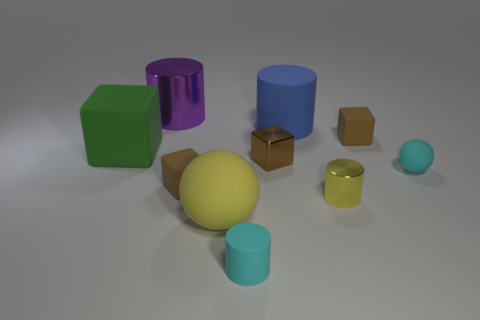How many cyan things are either big metal cylinders or balls?
Give a very brief answer. 1. Is there any other thing that has the same color as the large shiny cylinder?
Offer a terse response. No. What color is the rubber cylinder that is in front of the small brown cube that is to the right of the large blue cylinder?
Your answer should be very brief. Cyan. Is the number of large blue cylinders behind the big blue cylinder less than the number of large purple objects behind the big green rubber thing?
Your answer should be very brief. Yes. What material is the small ball that is the same color as the tiny matte cylinder?
Give a very brief answer. Rubber. How many objects are cyan matte objects on the right side of the small cyan cylinder or large green blocks?
Your answer should be compact. 2. There is a sphere that is on the right side of the shiny block; is it the same size as the yellow metal cylinder?
Offer a terse response. Yes. Are there fewer big green cubes that are in front of the small sphere than large balls?
Keep it short and to the point. Yes. What is the material of the yellow cylinder that is the same size as the cyan sphere?
Ensure brevity in your answer.  Metal. What number of large things are either yellow rubber spheres or green shiny objects?
Ensure brevity in your answer.  1. 